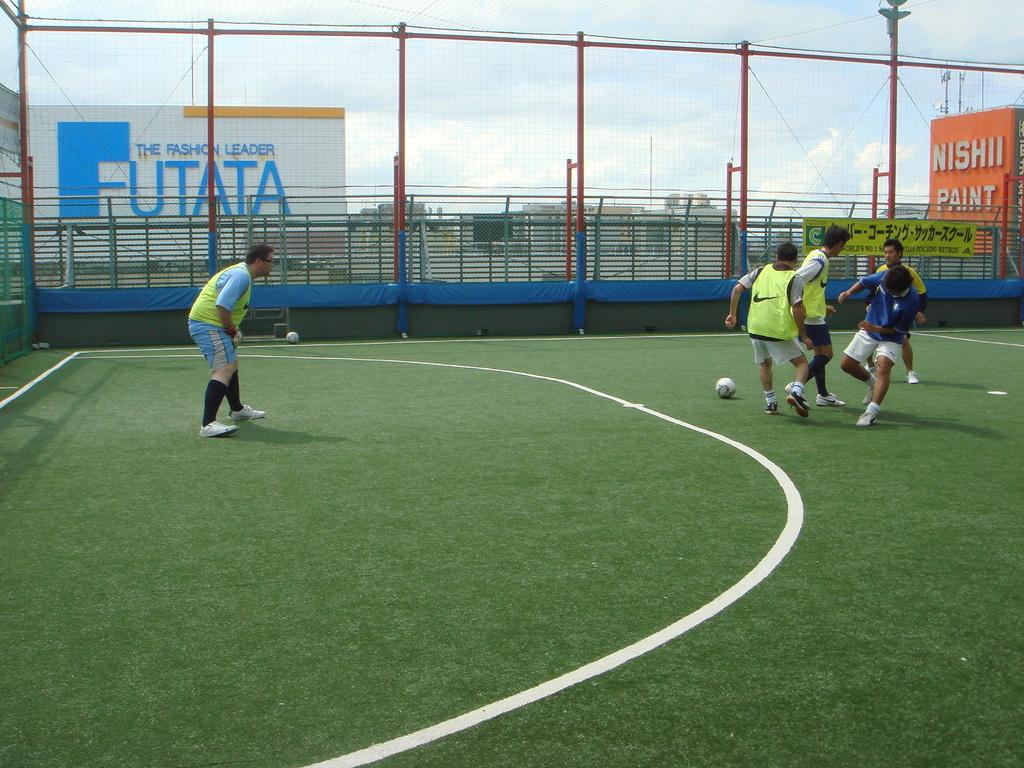Brand name in the white sign back there?
Give a very brief answer. Futata. What kind of paint is it?
Keep it short and to the point. Nishii. 